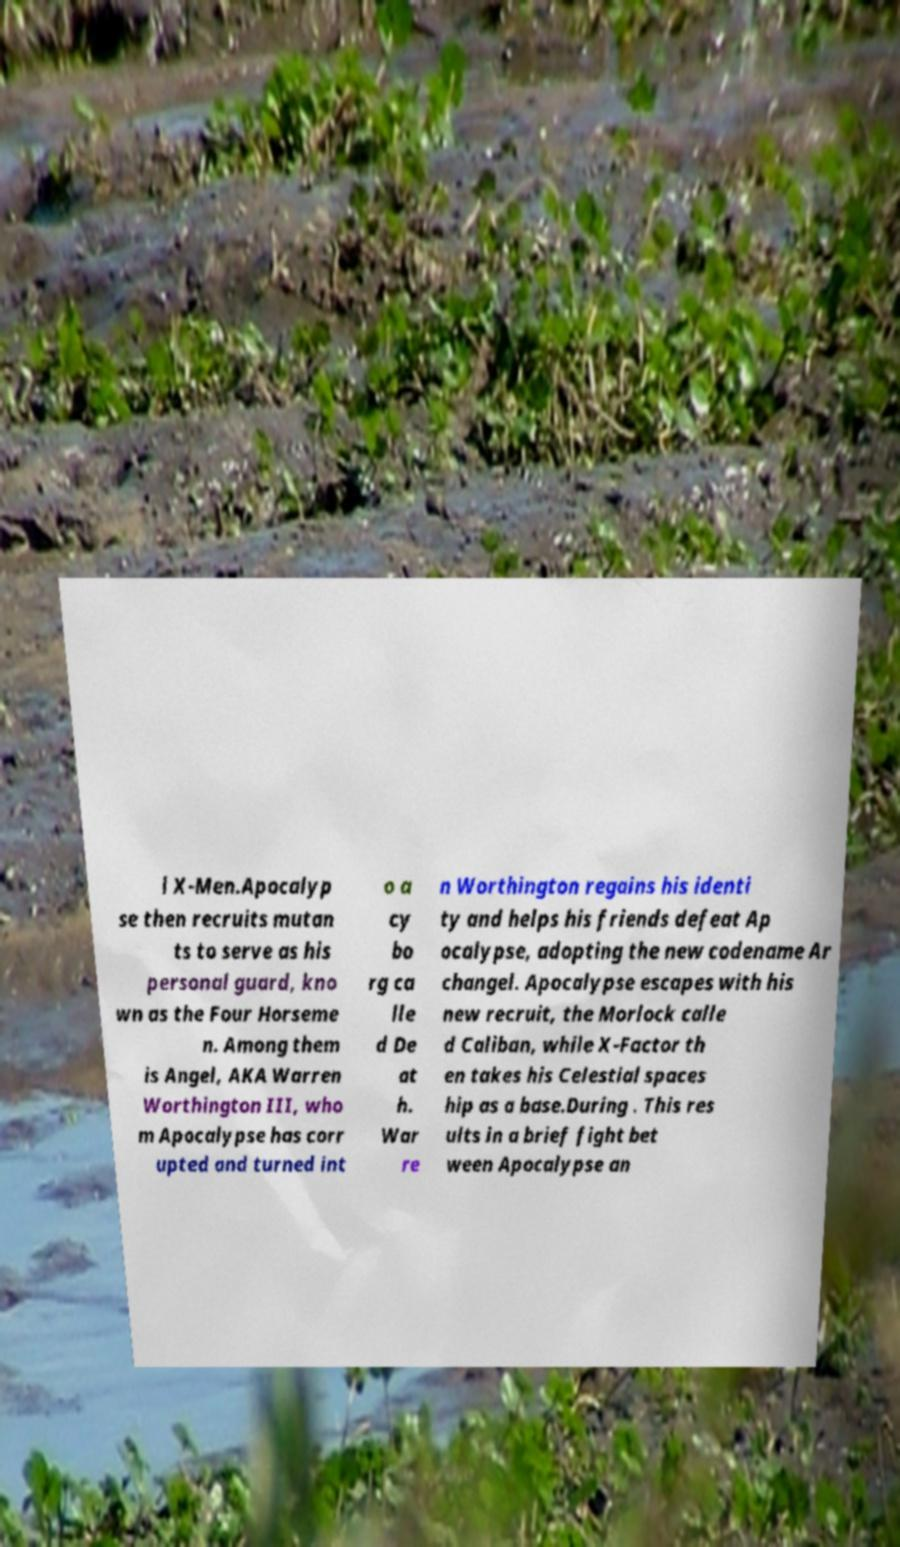There's text embedded in this image that I need extracted. Can you transcribe it verbatim? l X-Men.Apocalyp se then recruits mutan ts to serve as his personal guard, kno wn as the Four Horseme n. Among them is Angel, AKA Warren Worthington III, who m Apocalypse has corr upted and turned int o a cy bo rg ca lle d De at h. War re n Worthington regains his identi ty and helps his friends defeat Ap ocalypse, adopting the new codename Ar changel. Apocalypse escapes with his new recruit, the Morlock calle d Caliban, while X-Factor th en takes his Celestial spaces hip as a base.During . This res ults in a brief fight bet ween Apocalypse an 